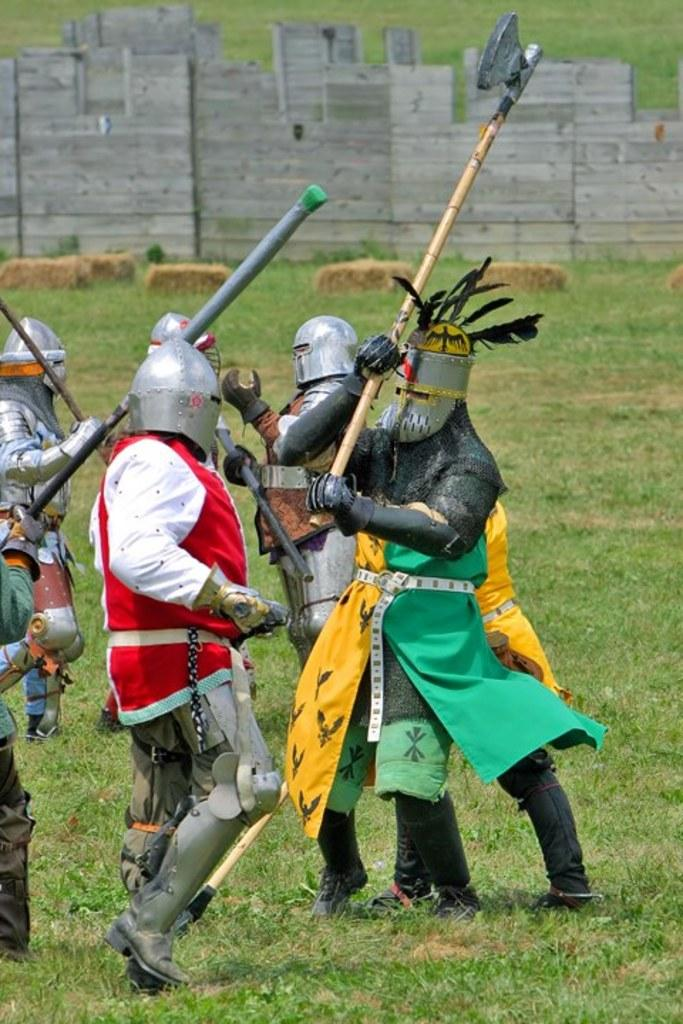Who or what can be seen in the image? There are people in the image. What are the people wearing on their faces? The people are wearing face masks. What are the people holding in their hands? The people are holding weapons. What can be seen in the background of the image? There is a wall in the background of the image. What type of ground is visible at the bottom of the image? There is grass visible at the bottom of the image. What type of dust can be seen on the ground in the image? There is no dust visible on the ground in the image; it is grass that can be seen. Is the person's brother also present in the image? There is no information about a brother or any other specific individuals in the image, only that there are people present. 